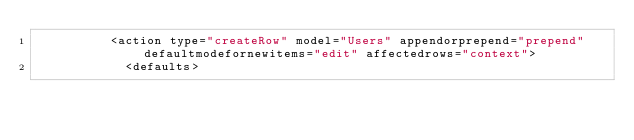Convert code to text. <code><loc_0><loc_0><loc_500><loc_500><_XML_>          <action type="createRow" model="Users" appendorprepend="prepend" defaultmodefornewitems="edit" affectedrows="context">
            <defaults></code> 